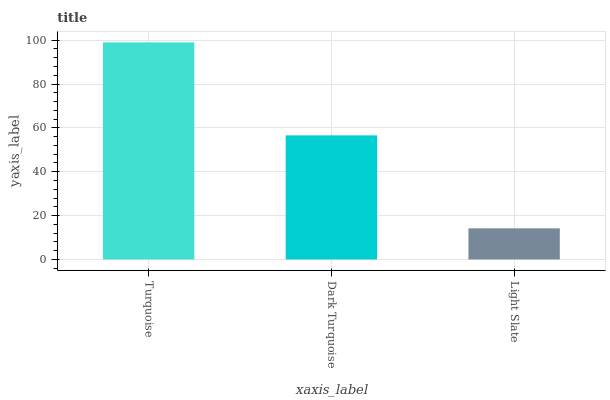Is Light Slate the minimum?
Answer yes or no. Yes. Is Turquoise the maximum?
Answer yes or no. Yes. Is Dark Turquoise the minimum?
Answer yes or no. No. Is Dark Turquoise the maximum?
Answer yes or no. No. Is Turquoise greater than Dark Turquoise?
Answer yes or no. Yes. Is Dark Turquoise less than Turquoise?
Answer yes or no. Yes. Is Dark Turquoise greater than Turquoise?
Answer yes or no. No. Is Turquoise less than Dark Turquoise?
Answer yes or no. No. Is Dark Turquoise the high median?
Answer yes or no. Yes. Is Dark Turquoise the low median?
Answer yes or no. Yes. Is Light Slate the high median?
Answer yes or no. No. Is Turquoise the low median?
Answer yes or no. No. 